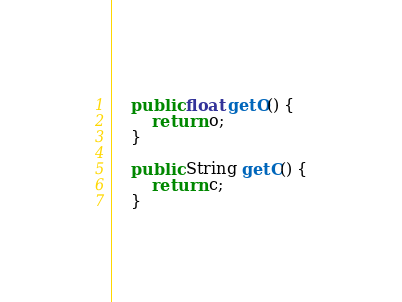<code> <loc_0><loc_0><loc_500><loc_500><_Java_>    public float getO() {
        return o;
    }

    public String getC() {
        return c;
    }
</code> 